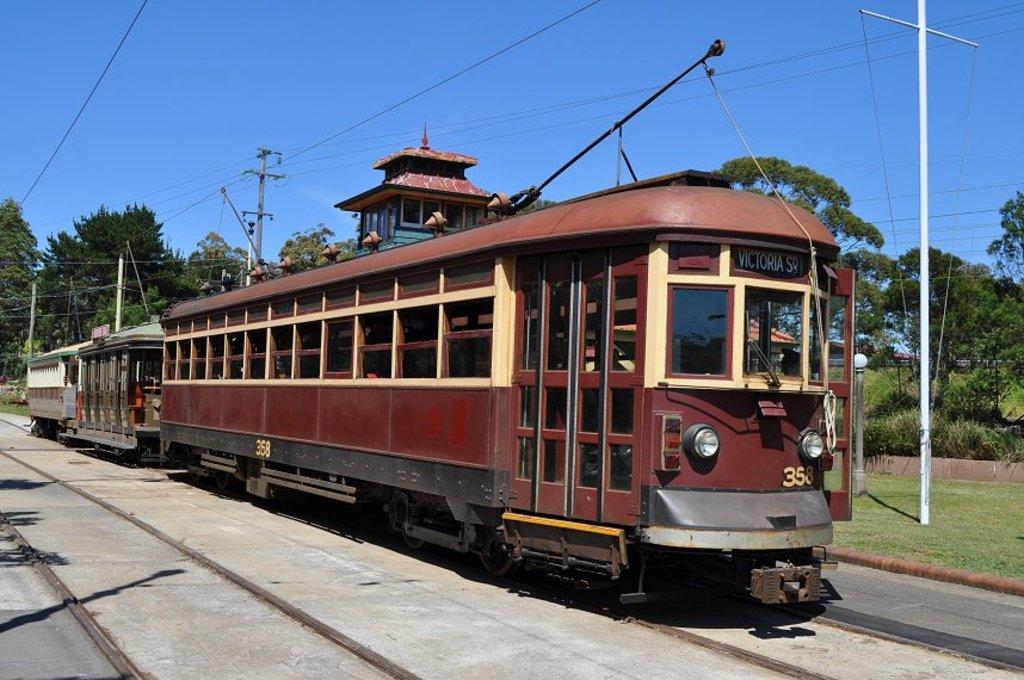What is the main subject of the image? The main subject of the image is a train. Can you describe the train's position in the image? The train is on a track. What can be seen in the background of the image? In the background of the image, there are poles, cables, trees, and houses. What type of star can be seen shining brightly in the image? There is no star visible in the image; it features a train on a track with a background of poles, cables, trees, and houses. 